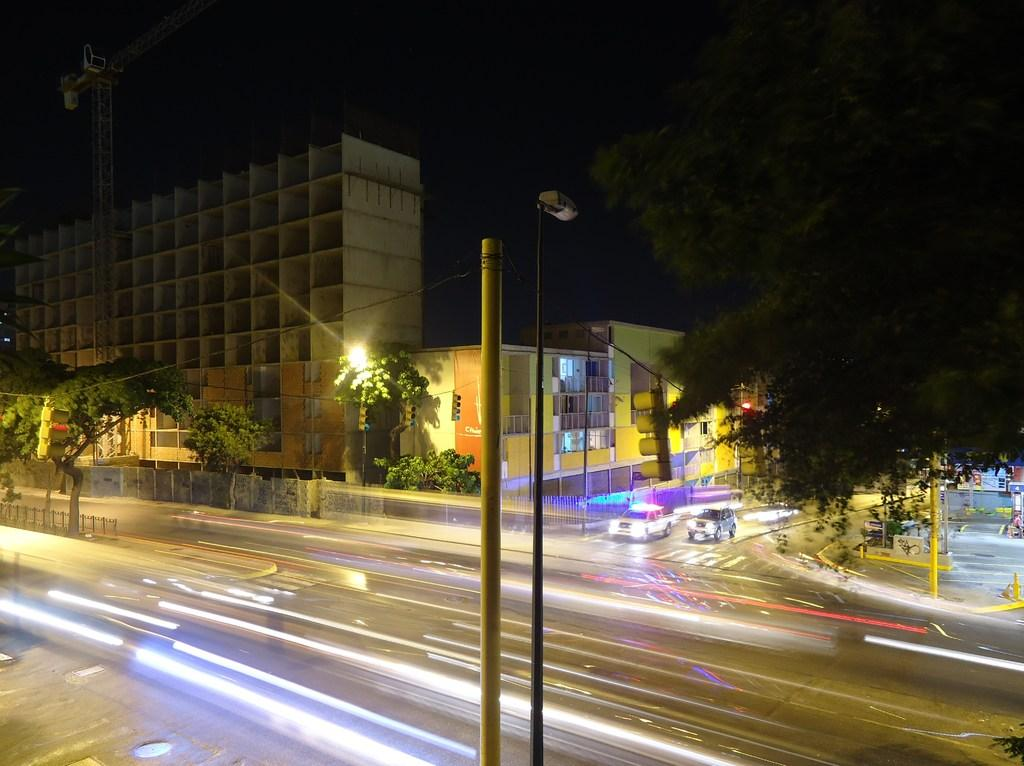What type of structures can be seen in the image? There are buildings in the image. What type of lighting is present along the road in the image? Street lights are present in the image. What type of transportation is visible on the road in the image? Vehicles are visible on the road in the image. What type of vegetation is present in the image? Trees are present in the image. What type of vertical structures are visible in the image? Poles are visible in the image. What type of barrier is present in the image? There is a fence in the image. What can be seen in the background of the image? The sky is visible in the background of the image. What type of metal is used to construct the building in the image? There is no specific information about the type of metal used to construct the building in the image. What type of hope is depicted in the image? There is no depiction of hope in the image; it primarily features buildings, street lights, vehicles, trees, poles, a fence, and the sky. 